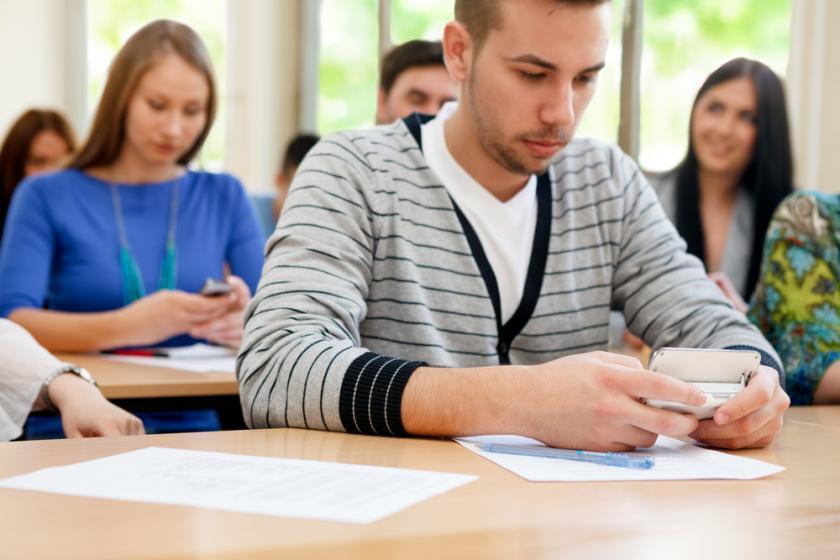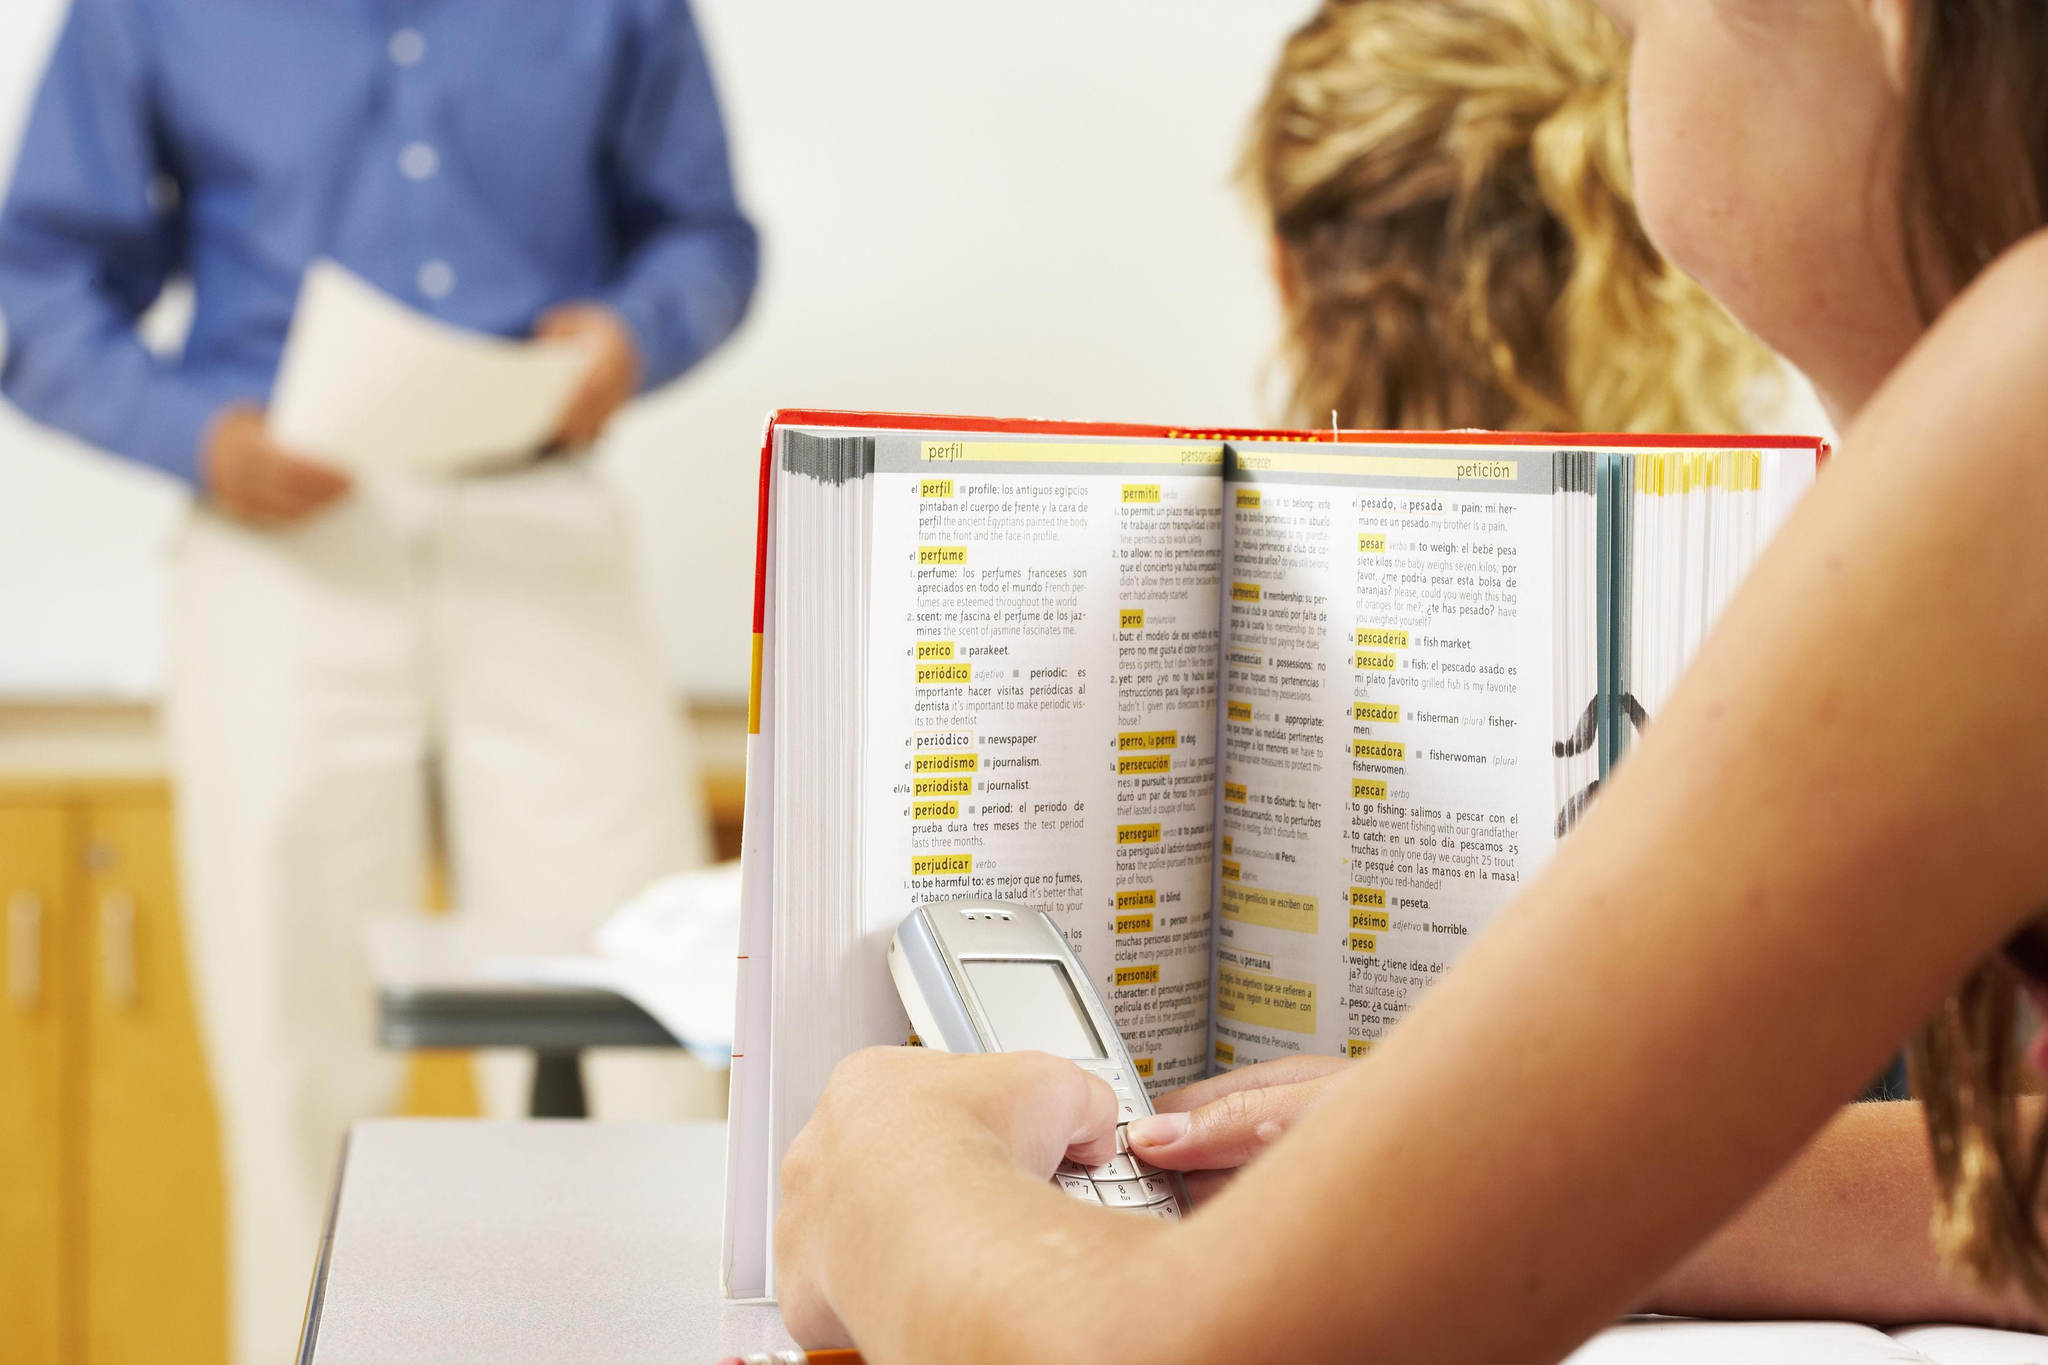The first image is the image on the left, the second image is the image on the right. For the images displayed, is the sentence "A person is driving and holding a cell phone in the left image." factually correct? Answer yes or no. No. The first image is the image on the left, the second image is the image on the right. Evaluate the accuracy of this statement regarding the images: "A person is using a cell phone while in a car.". Is it true? Answer yes or no. No. 